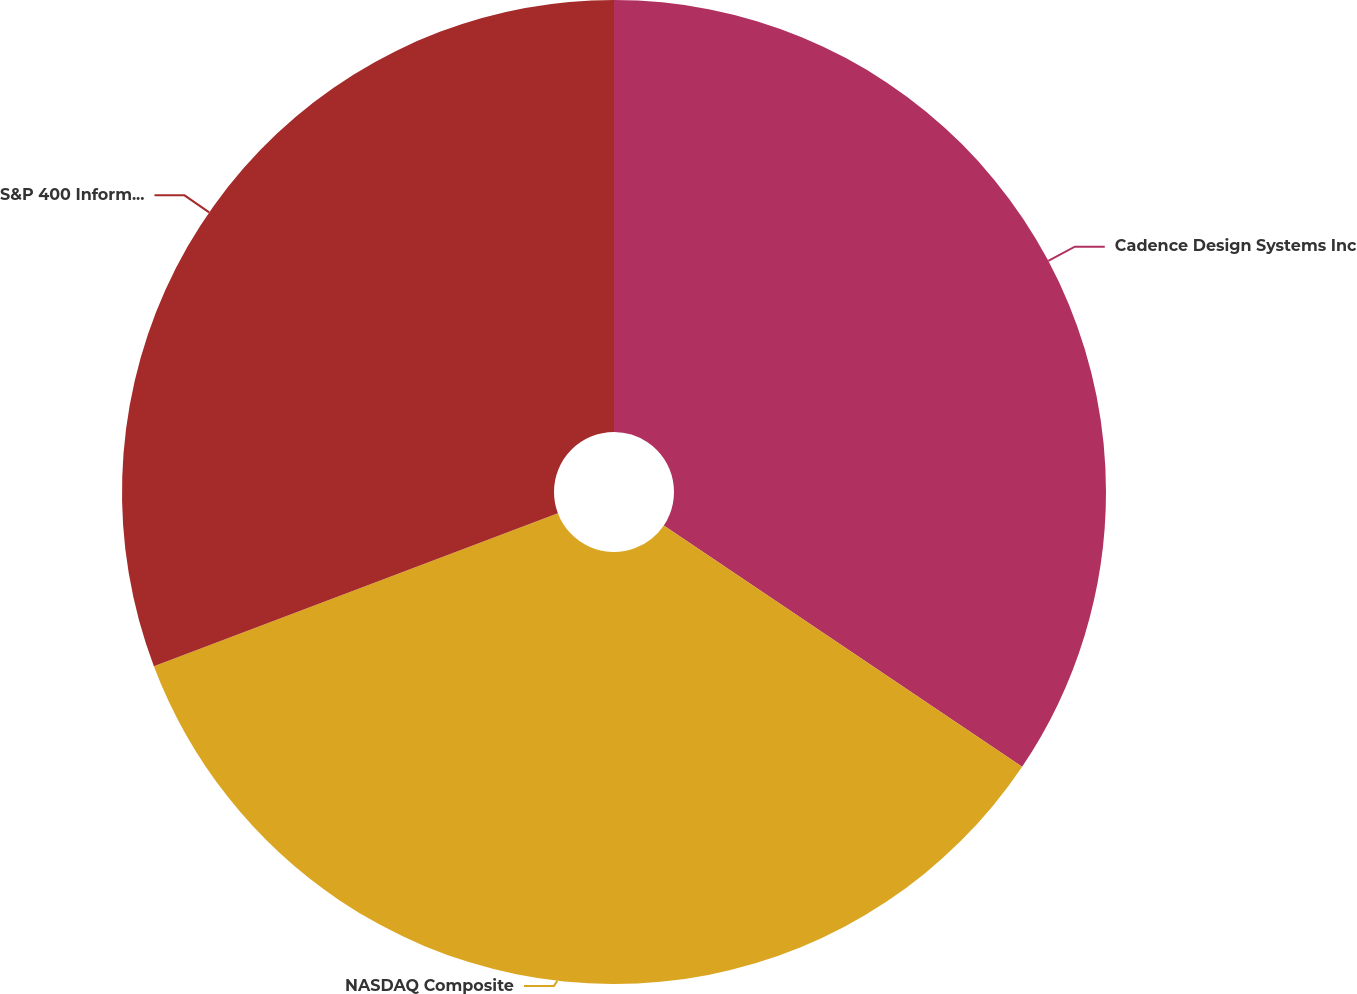Convert chart to OTSL. <chart><loc_0><loc_0><loc_500><loc_500><pie_chart><fcel>Cadence Design Systems Inc<fcel>NASDAQ Composite<fcel>S&P 400 Information Technology<nl><fcel>34.43%<fcel>34.81%<fcel>30.76%<nl></chart> 